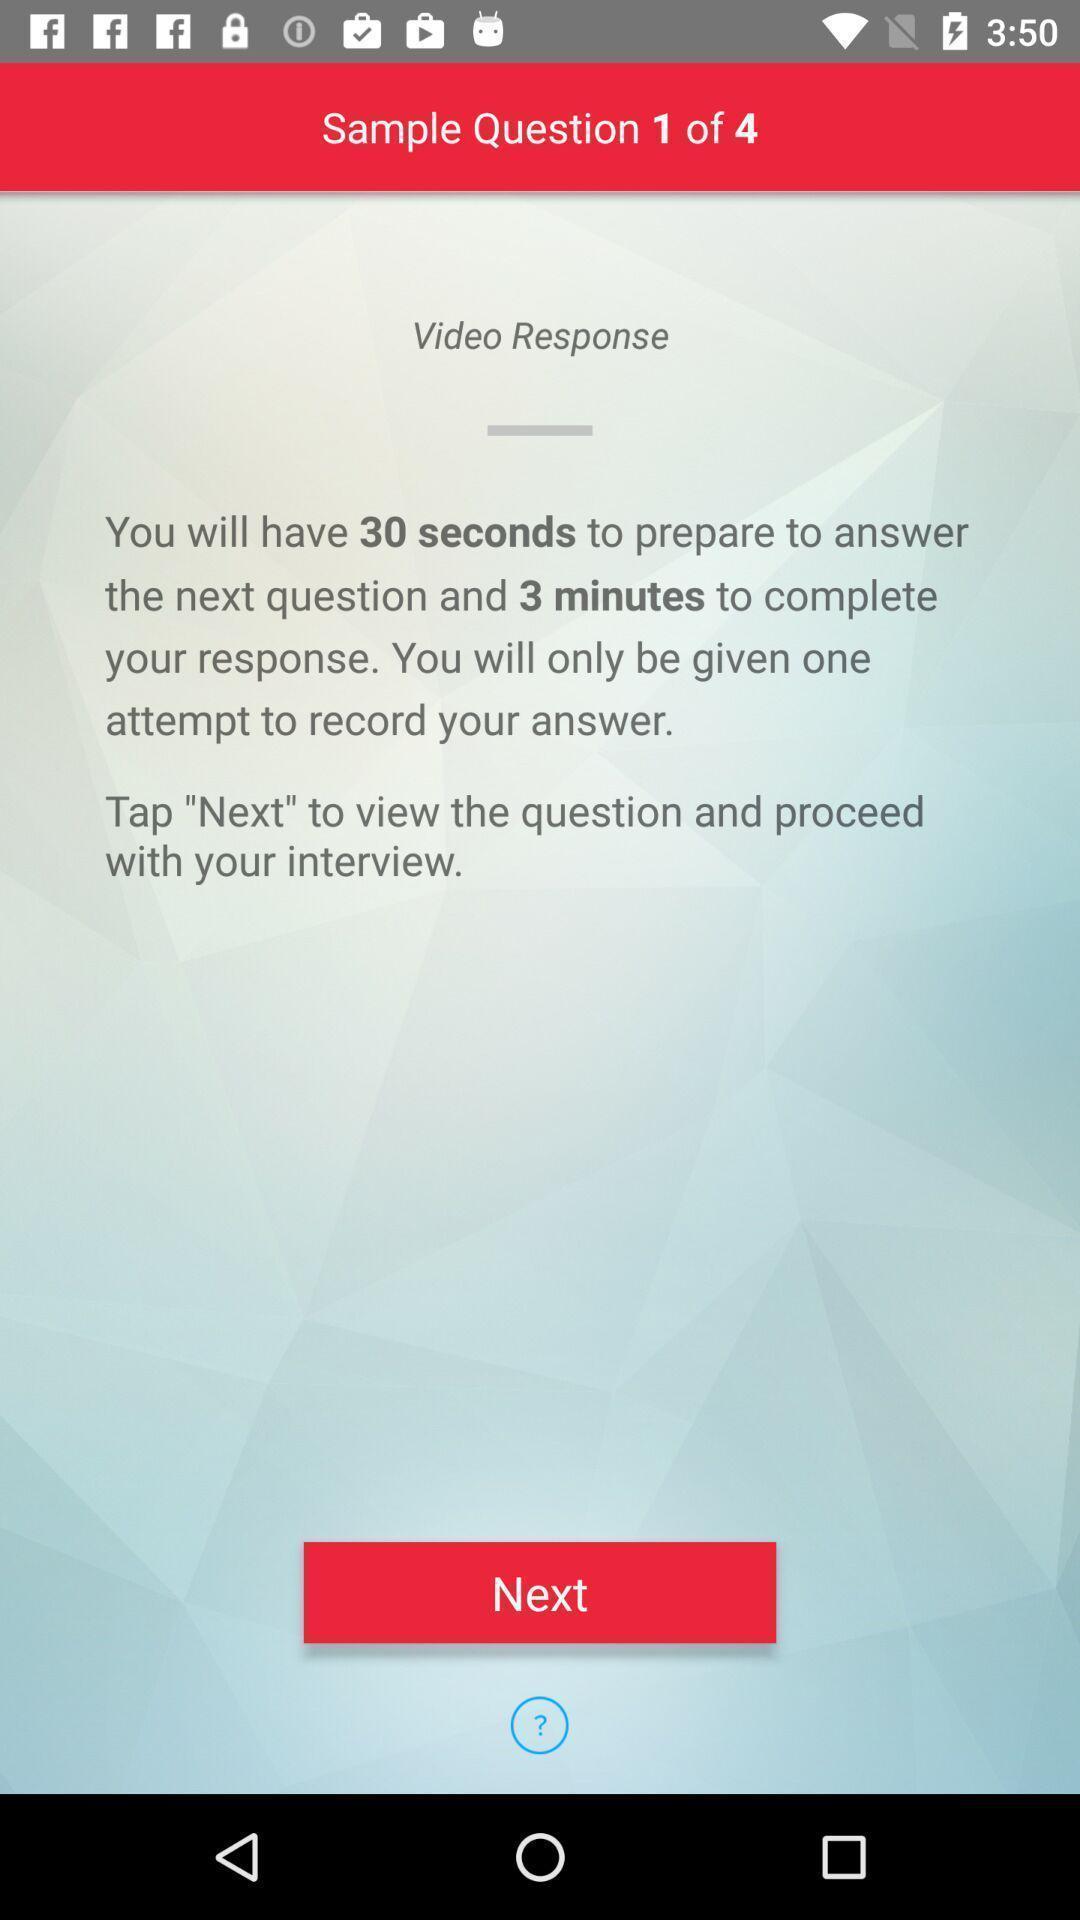Explain what's happening in this screen capture. Screen showing sample question. 